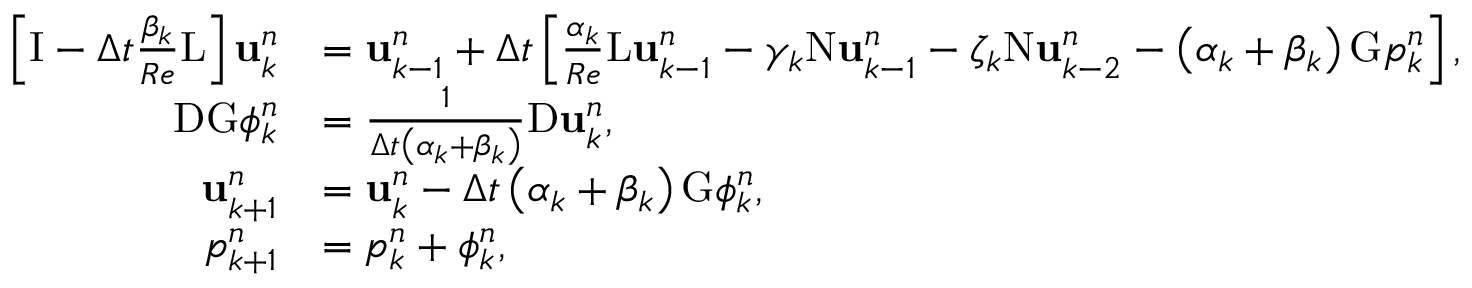<formula> <loc_0><loc_0><loc_500><loc_500>\begin{array} { r l } { \left [ I - \Delta t \frac { \beta _ { k } } { R e } L \right ] u _ { k } ^ { n } } & { = u _ { k - 1 } ^ { n } + \Delta t \left [ \frac { \alpha _ { k } } { R e } L u _ { k - 1 } ^ { n } - \gamma _ { k } N u _ { k - 1 } ^ { n } - \zeta _ { k } N u _ { k - 2 } ^ { n } - \left ( \alpha _ { k } + \beta _ { k } \right ) G p _ { k } ^ { n } \right ] , } \\ { D G \phi _ { k } ^ { n } } & { = \frac { 1 } { \Delta t \left ( \alpha _ { k } + \beta _ { k } \right ) } D u _ { k } ^ { n } , } \\ { u _ { k + 1 } ^ { n } } & { = u _ { k } ^ { n } - \Delta t \left ( \alpha _ { k } + \beta _ { k } \right ) G \phi _ { k } ^ { n } , } \\ { p _ { k + 1 } ^ { n } } & { = p _ { k } ^ { n } + \phi _ { k } ^ { n } , } \end{array}</formula> 